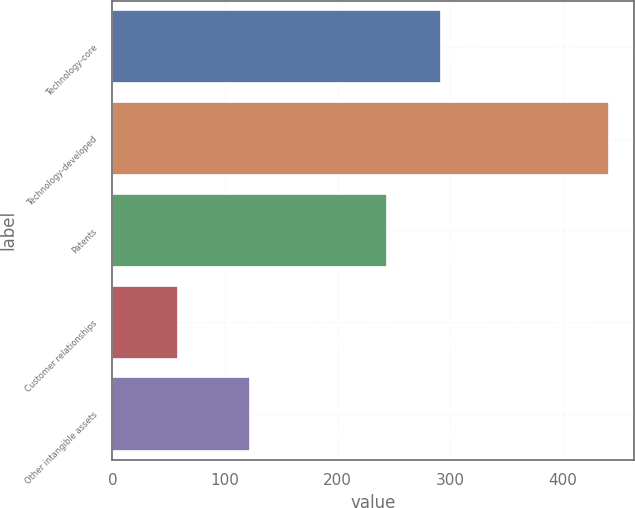<chart> <loc_0><loc_0><loc_500><loc_500><bar_chart><fcel>Technology-core<fcel>Technology-developed<fcel>Patents<fcel>Customer relationships<fcel>Other intangible assets<nl><fcel>292<fcel>441<fcel>244<fcel>58<fcel>122<nl></chart> 